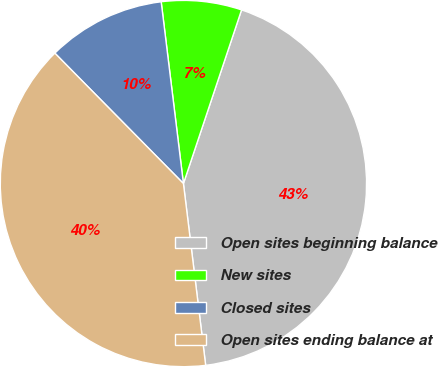Convert chart. <chart><loc_0><loc_0><loc_500><loc_500><pie_chart><fcel>Open sites beginning balance<fcel>New sites<fcel>Closed sites<fcel>Open sites ending balance at<nl><fcel>42.92%<fcel>7.08%<fcel>10.45%<fcel>39.55%<nl></chart> 